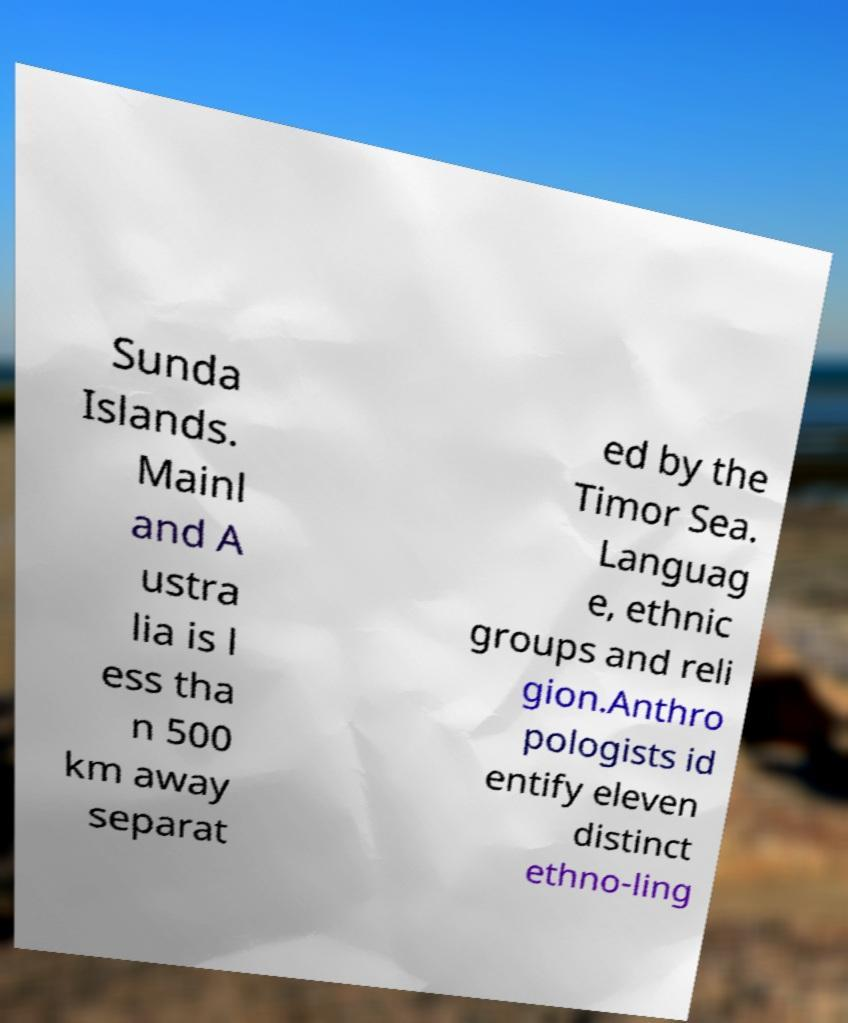Could you assist in decoding the text presented in this image and type it out clearly? Sunda Islands. Mainl and A ustra lia is l ess tha n 500 km away separat ed by the Timor Sea. Languag e, ethnic groups and reli gion.Anthro pologists id entify eleven distinct ethno-ling 